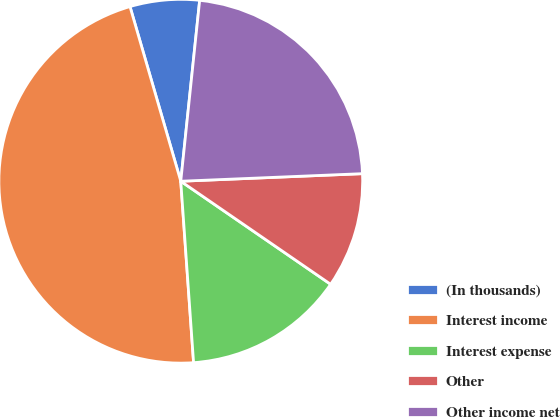Convert chart. <chart><loc_0><loc_0><loc_500><loc_500><pie_chart><fcel>(In thousands)<fcel>Interest income<fcel>Interest expense<fcel>Other<fcel>Other income net<nl><fcel>6.16%<fcel>46.62%<fcel>14.29%<fcel>10.25%<fcel>22.68%<nl></chart> 